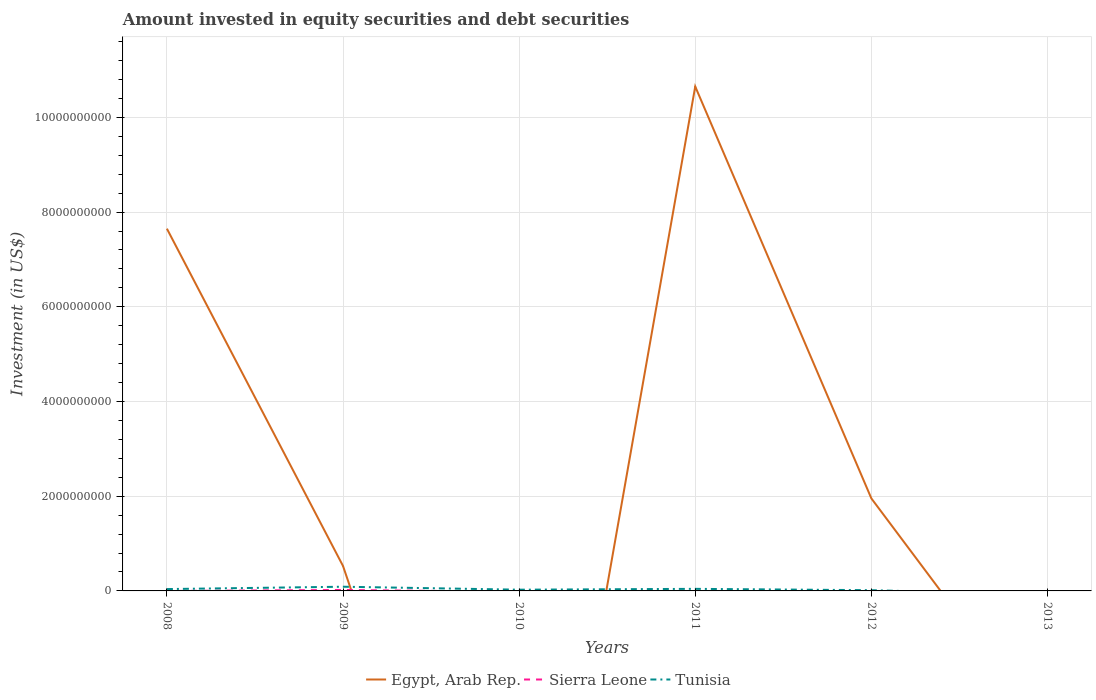How many different coloured lines are there?
Offer a terse response. 3. Does the line corresponding to Sierra Leone intersect with the line corresponding to Tunisia?
Offer a terse response. Yes. Is the number of lines equal to the number of legend labels?
Make the answer very short. No. What is the total amount invested in equity securities and debt securities in Egypt, Arab Rep. in the graph?
Your answer should be compact. 5.70e+09. What is the difference between the highest and the second highest amount invested in equity securities and debt securities in Tunisia?
Provide a succinct answer. 8.86e+07. What is the difference between the highest and the lowest amount invested in equity securities and debt securities in Tunisia?
Offer a very short reply. 3. How many lines are there?
Your answer should be compact. 3. What is the difference between two consecutive major ticks on the Y-axis?
Ensure brevity in your answer.  2.00e+09. Does the graph contain any zero values?
Your response must be concise. Yes. Does the graph contain grids?
Provide a succinct answer. Yes. How many legend labels are there?
Your answer should be very brief. 3. How are the legend labels stacked?
Provide a short and direct response. Horizontal. What is the title of the graph?
Offer a very short reply. Amount invested in equity securities and debt securities. What is the label or title of the Y-axis?
Make the answer very short. Investment (in US$). What is the Investment (in US$) of Egypt, Arab Rep. in 2008?
Offer a very short reply. 7.65e+09. What is the Investment (in US$) in Tunisia in 2008?
Offer a terse response. 3.90e+07. What is the Investment (in US$) of Egypt, Arab Rep. in 2009?
Provide a short and direct response. 5.27e+08. What is the Investment (in US$) of Sierra Leone in 2009?
Offer a very short reply. 2.03e+07. What is the Investment (in US$) in Tunisia in 2009?
Ensure brevity in your answer.  8.86e+07. What is the Investment (in US$) in Egypt, Arab Rep. in 2010?
Ensure brevity in your answer.  0. What is the Investment (in US$) in Tunisia in 2010?
Offer a terse response. 2.59e+07. What is the Investment (in US$) of Egypt, Arab Rep. in 2011?
Give a very brief answer. 1.07e+1. What is the Investment (in US$) of Sierra Leone in 2011?
Make the answer very short. 0. What is the Investment (in US$) of Tunisia in 2011?
Your answer should be very brief. 4.38e+07. What is the Investment (in US$) in Egypt, Arab Rep. in 2012?
Offer a very short reply. 1.95e+09. What is the Investment (in US$) of Sierra Leone in 2012?
Offer a terse response. 0. What is the Investment (in US$) of Tunisia in 2012?
Your response must be concise. 1.54e+07. What is the Investment (in US$) of Egypt, Arab Rep. in 2013?
Provide a succinct answer. 0. What is the Investment (in US$) of Sierra Leone in 2013?
Offer a terse response. 0. Across all years, what is the maximum Investment (in US$) in Egypt, Arab Rep.?
Provide a short and direct response. 1.07e+1. Across all years, what is the maximum Investment (in US$) of Sierra Leone?
Your answer should be very brief. 2.03e+07. Across all years, what is the maximum Investment (in US$) in Tunisia?
Give a very brief answer. 8.86e+07. What is the total Investment (in US$) in Egypt, Arab Rep. in the graph?
Your answer should be compact. 2.08e+1. What is the total Investment (in US$) in Sierra Leone in the graph?
Give a very brief answer. 2.03e+07. What is the total Investment (in US$) in Tunisia in the graph?
Keep it short and to the point. 2.13e+08. What is the difference between the Investment (in US$) in Egypt, Arab Rep. in 2008 and that in 2009?
Your answer should be very brief. 7.12e+09. What is the difference between the Investment (in US$) in Tunisia in 2008 and that in 2009?
Keep it short and to the point. -4.96e+07. What is the difference between the Investment (in US$) in Tunisia in 2008 and that in 2010?
Offer a terse response. 1.31e+07. What is the difference between the Investment (in US$) of Egypt, Arab Rep. in 2008 and that in 2011?
Make the answer very short. -3.00e+09. What is the difference between the Investment (in US$) of Tunisia in 2008 and that in 2011?
Your answer should be very brief. -4.72e+06. What is the difference between the Investment (in US$) in Egypt, Arab Rep. in 2008 and that in 2012?
Make the answer very short. 5.70e+09. What is the difference between the Investment (in US$) of Tunisia in 2008 and that in 2012?
Give a very brief answer. 2.37e+07. What is the difference between the Investment (in US$) of Tunisia in 2009 and that in 2010?
Keep it short and to the point. 6.27e+07. What is the difference between the Investment (in US$) in Egypt, Arab Rep. in 2009 and that in 2011?
Provide a succinct answer. -1.01e+1. What is the difference between the Investment (in US$) in Tunisia in 2009 and that in 2011?
Your answer should be very brief. 4.49e+07. What is the difference between the Investment (in US$) of Egypt, Arab Rep. in 2009 and that in 2012?
Your answer should be very brief. -1.43e+09. What is the difference between the Investment (in US$) of Tunisia in 2009 and that in 2012?
Give a very brief answer. 7.33e+07. What is the difference between the Investment (in US$) in Tunisia in 2010 and that in 2011?
Provide a succinct answer. -1.78e+07. What is the difference between the Investment (in US$) of Tunisia in 2010 and that in 2012?
Offer a terse response. 1.06e+07. What is the difference between the Investment (in US$) of Egypt, Arab Rep. in 2011 and that in 2012?
Your answer should be very brief. 8.70e+09. What is the difference between the Investment (in US$) of Tunisia in 2011 and that in 2012?
Ensure brevity in your answer.  2.84e+07. What is the difference between the Investment (in US$) in Egypt, Arab Rep. in 2008 and the Investment (in US$) in Sierra Leone in 2009?
Provide a succinct answer. 7.63e+09. What is the difference between the Investment (in US$) of Egypt, Arab Rep. in 2008 and the Investment (in US$) of Tunisia in 2009?
Your answer should be compact. 7.56e+09. What is the difference between the Investment (in US$) in Egypt, Arab Rep. in 2008 and the Investment (in US$) in Tunisia in 2010?
Keep it short and to the point. 7.62e+09. What is the difference between the Investment (in US$) in Egypt, Arab Rep. in 2008 and the Investment (in US$) in Tunisia in 2011?
Provide a succinct answer. 7.61e+09. What is the difference between the Investment (in US$) of Egypt, Arab Rep. in 2008 and the Investment (in US$) of Tunisia in 2012?
Provide a short and direct response. 7.63e+09. What is the difference between the Investment (in US$) of Egypt, Arab Rep. in 2009 and the Investment (in US$) of Tunisia in 2010?
Provide a short and direct response. 5.01e+08. What is the difference between the Investment (in US$) in Sierra Leone in 2009 and the Investment (in US$) in Tunisia in 2010?
Your answer should be compact. -5.59e+06. What is the difference between the Investment (in US$) in Egypt, Arab Rep. in 2009 and the Investment (in US$) in Tunisia in 2011?
Ensure brevity in your answer.  4.83e+08. What is the difference between the Investment (in US$) in Sierra Leone in 2009 and the Investment (in US$) in Tunisia in 2011?
Give a very brief answer. -2.34e+07. What is the difference between the Investment (in US$) of Egypt, Arab Rep. in 2009 and the Investment (in US$) of Tunisia in 2012?
Your answer should be compact. 5.12e+08. What is the difference between the Investment (in US$) of Sierra Leone in 2009 and the Investment (in US$) of Tunisia in 2012?
Provide a succinct answer. 4.96e+06. What is the difference between the Investment (in US$) in Egypt, Arab Rep. in 2011 and the Investment (in US$) in Tunisia in 2012?
Give a very brief answer. 1.06e+1. What is the average Investment (in US$) in Egypt, Arab Rep. per year?
Your answer should be compact. 3.46e+09. What is the average Investment (in US$) in Sierra Leone per year?
Keep it short and to the point. 3.39e+06. What is the average Investment (in US$) in Tunisia per year?
Your response must be concise. 3.55e+07. In the year 2008, what is the difference between the Investment (in US$) in Egypt, Arab Rep. and Investment (in US$) in Tunisia?
Your answer should be very brief. 7.61e+09. In the year 2009, what is the difference between the Investment (in US$) in Egypt, Arab Rep. and Investment (in US$) in Sierra Leone?
Your answer should be compact. 5.07e+08. In the year 2009, what is the difference between the Investment (in US$) in Egypt, Arab Rep. and Investment (in US$) in Tunisia?
Ensure brevity in your answer.  4.38e+08. In the year 2009, what is the difference between the Investment (in US$) in Sierra Leone and Investment (in US$) in Tunisia?
Provide a succinct answer. -6.83e+07. In the year 2011, what is the difference between the Investment (in US$) of Egypt, Arab Rep. and Investment (in US$) of Tunisia?
Offer a very short reply. 1.06e+1. In the year 2012, what is the difference between the Investment (in US$) of Egypt, Arab Rep. and Investment (in US$) of Tunisia?
Your response must be concise. 1.94e+09. What is the ratio of the Investment (in US$) of Egypt, Arab Rep. in 2008 to that in 2009?
Your response must be concise. 14.51. What is the ratio of the Investment (in US$) of Tunisia in 2008 to that in 2009?
Keep it short and to the point. 0.44. What is the ratio of the Investment (in US$) of Tunisia in 2008 to that in 2010?
Your answer should be compact. 1.51. What is the ratio of the Investment (in US$) of Egypt, Arab Rep. in 2008 to that in 2011?
Your answer should be very brief. 0.72. What is the ratio of the Investment (in US$) in Tunisia in 2008 to that in 2011?
Your answer should be very brief. 0.89. What is the ratio of the Investment (in US$) of Egypt, Arab Rep. in 2008 to that in 2012?
Your answer should be very brief. 3.92. What is the ratio of the Investment (in US$) of Tunisia in 2008 to that in 2012?
Your answer should be very brief. 2.54. What is the ratio of the Investment (in US$) in Tunisia in 2009 to that in 2010?
Keep it short and to the point. 3.42. What is the ratio of the Investment (in US$) of Egypt, Arab Rep. in 2009 to that in 2011?
Give a very brief answer. 0.05. What is the ratio of the Investment (in US$) in Tunisia in 2009 to that in 2011?
Your answer should be compact. 2.03. What is the ratio of the Investment (in US$) of Egypt, Arab Rep. in 2009 to that in 2012?
Provide a short and direct response. 0.27. What is the ratio of the Investment (in US$) of Tunisia in 2009 to that in 2012?
Offer a very short reply. 5.77. What is the ratio of the Investment (in US$) of Tunisia in 2010 to that in 2011?
Your answer should be very brief. 0.59. What is the ratio of the Investment (in US$) of Tunisia in 2010 to that in 2012?
Make the answer very short. 1.69. What is the ratio of the Investment (in US$) of Egypt, Arab Rep. in 2011 to that in 2012?
Offer a terse response. 5.45. What is the ratio of the Investment (in US$) in Tunisia in 2011 to that in 2012?
Make the answer very short. 2.85. What is the difference between the highest and the second highest Investment (in US$) in Egypt, Arab Rep.?
Give a very brief answer. 3.00e+09. What is the difference between the highest and the second highest Investment (in US$) in Tunisia?
Your answer should be very brief. 4.49e+07. What is the difference between the highest and the lowest Investment (in US$) in Egypt, Arab Rep.?
Offer a very short reply. 1.07e+1. What is the difference between the highest and the lowest Investment (in US$) in Sierra Leone?
Keep it short and to the point. 2.03e+07. What is the difference between the highest and the lowest Investment (in US$) of Tunisia?
Your answer should be compact. 8.86e+07. 